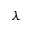Convert formula to latex. <formula><loc_0><loc_0><loc_500><loc_500>\lambda</formula> 